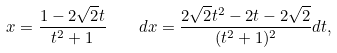<formula> <loc_0><loc_0><loc_500><loc_500>x = { \frac { 1 - 2 { \sqrt { 2 } } t } { t ^ { 2 } + 1 } } \quad d x = { \frac { 2 { \sqrt { 2 } } t ^ { 2 } - 2 t - 2 { \sqrt { 2 } } } { ( t ^ { 2 } + 1 ) ^ { 2 } } } d t ,</formula> 